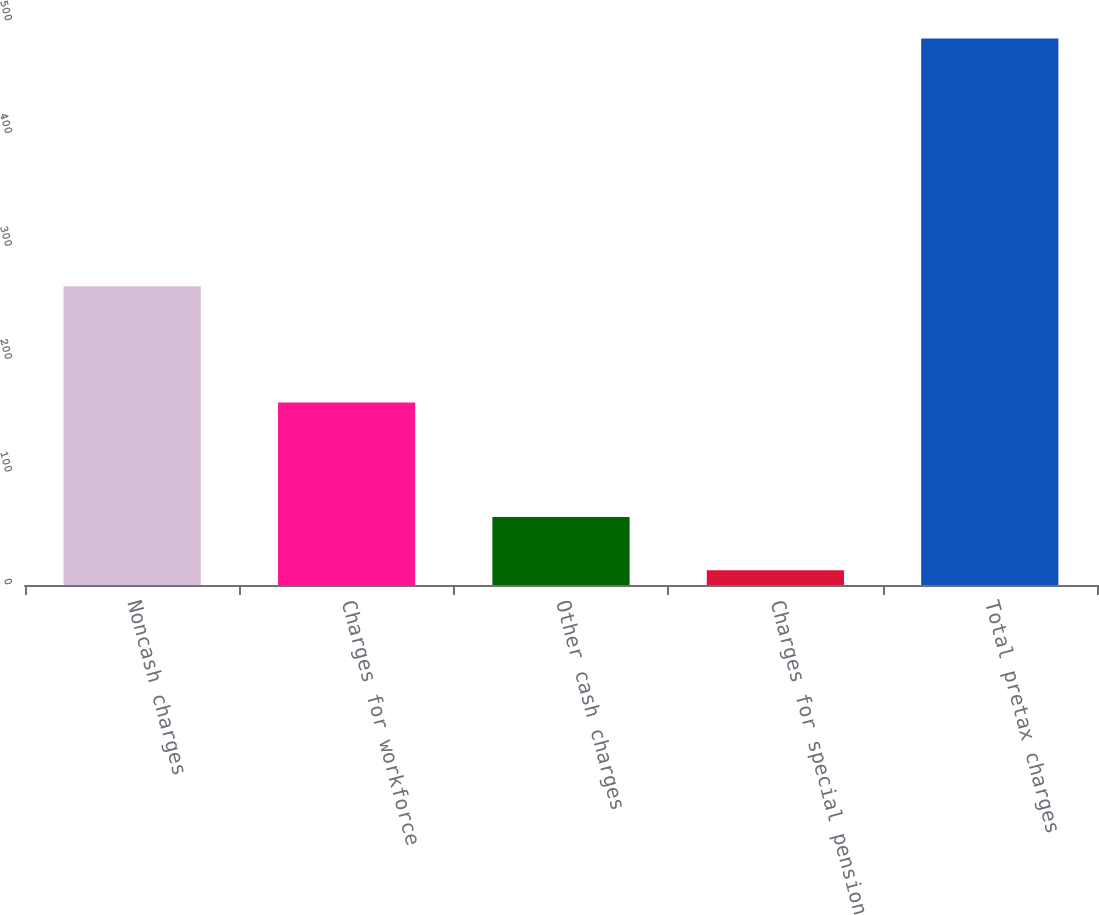<chart> <loc_0><loc_0><loc_500><loc_500><bar_chart><fcel>Noncash charges<fcel>Charges for workforce<fcel>Other cash charges<fcel>Charges for special pension<fcel>Total pretax charges<nl><fcel>264.8<fcel>161.9<fcel>60.23<fcel>13.1<fcel>484.4<nl></chart> 